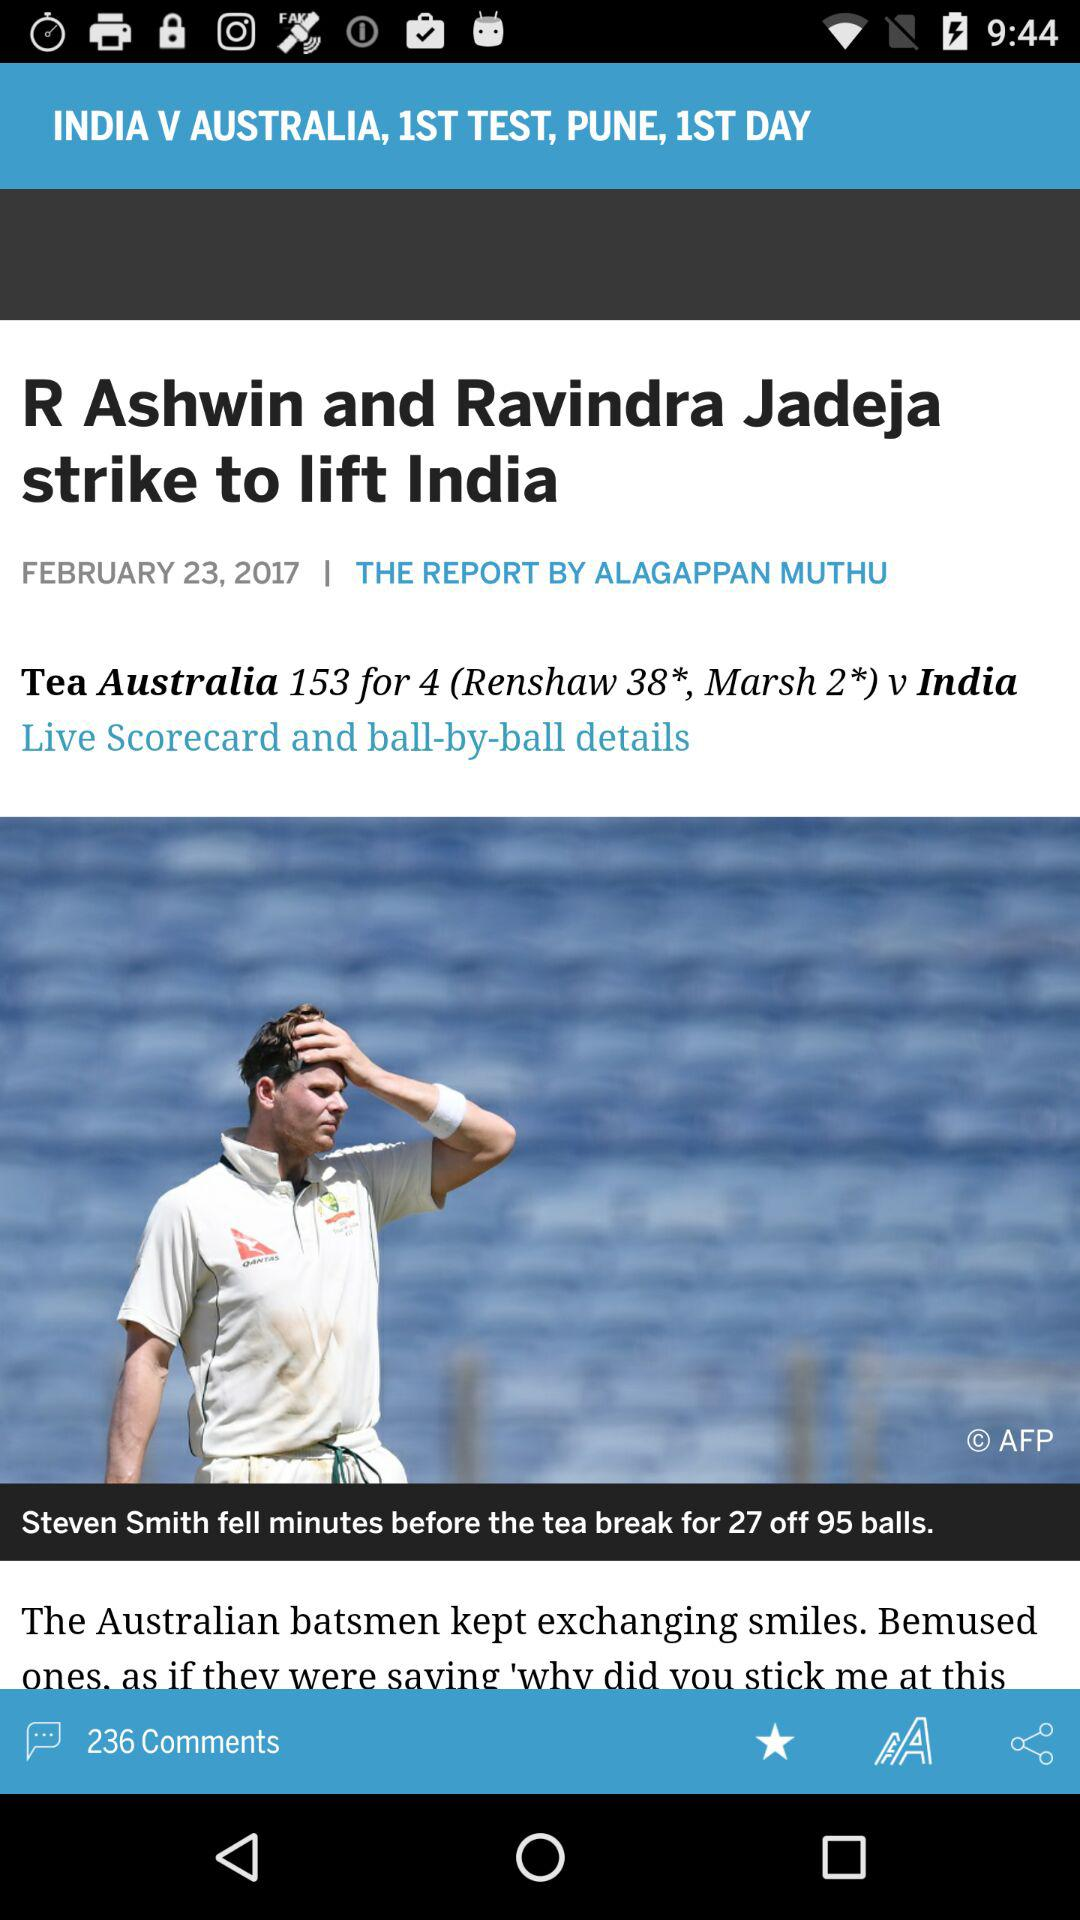Which test match is this? This is the first test match. 